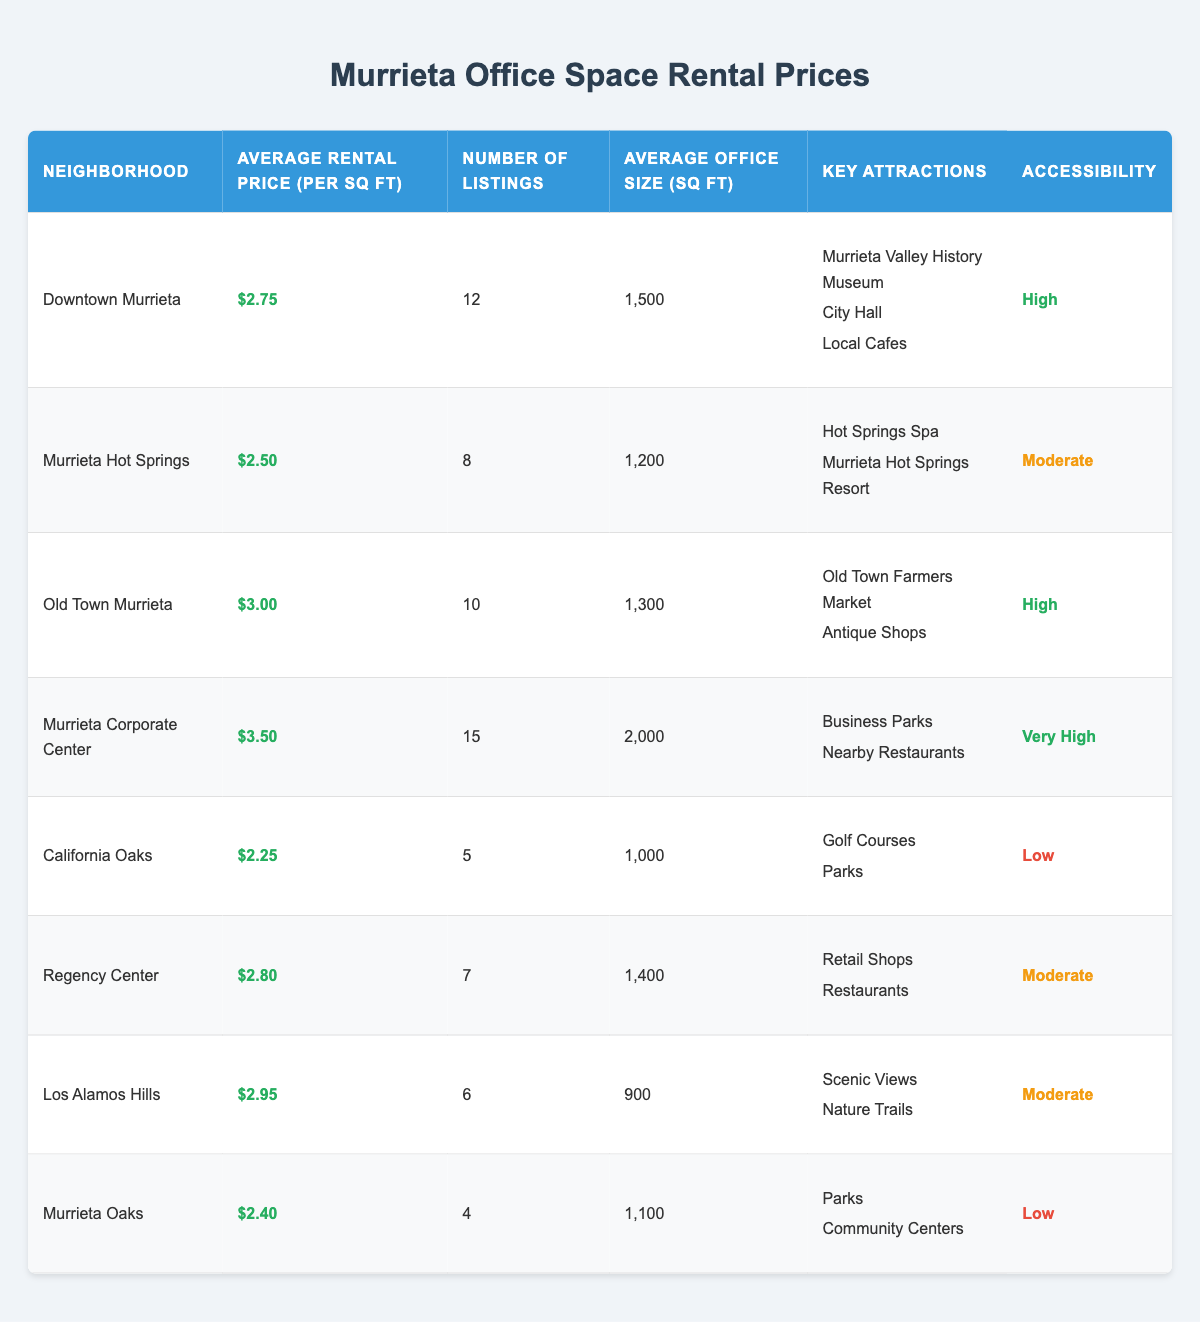What's the average rental price per square foot in Downtown Murrieta? The average rental price per square foot in Downtown Murrieta is listed in the table as $2.75.
Answer: $2.75 Which neighborhood has the highest average rental price per square foot? The neighborhood with the highest average rental price per square foot is Murrieta Corporate Center, with a price of $3.50.
Answer: Murrieta Corporate Center How many total listings are there across all neighborhoods? To find the total listings, I sum the number of listings for each neighborhood: 12 + 8 + 10 + 15 + 5 + 7 + 6 + 4 = 67.
Answer: 67 What is the average office size in square feet for Regency Center? The average office size for Regency Center is stated in the table as 1,400 square feet.
Answer: 1,400 Are there any neighborhoods with rental prices less than $2.50 per square foot? According to the table, the lowest rental price is $2.25 in California Oaks, which means there are neighborhoods with rental prices below $2.50.
Answer: Yes Which neighborhood has the lowest rental price per square foot? The neighborhood with the lowest rental price per square foot is California Oaks at $2.25.
Answer: California Oaks If you average the rental prices of California Oaks and Murrieta Hot Springs, what is the result? The rental prices are $2.25 (California Oaks) and $2.50 (Murrieta Hot Springs). The average is calculated as (2.25 + 2.50) / 2 = 2.375.
Answer: $2.375 Is the average size of office spaces larger in Downtown Murrieta or California Oaks? Downtown Murrieta has an average office size of 1,500 square feet, while California Oaks has 1,000 square feet. Therefore, Downtown Murrieta has a larger average size.
Answer: Downtown Murrieta What percentage of listings are found in the Murrieta Corporate Center? There are 15 listings in the Murrieta Corporate Center out of a total of 67 listings. The percentage is calculated as (15 / 67) * 100, which equals approximately 22.39%.
Answer: 22.39% Which neighborhood offers the most listings? The neighborhood with the most listings is Murrieta Corporate Center, which has 15 listings.
Answer: Murrieta Corporate Center How does the accessibility of Old Town Murrieta compare to California Oaks? Old Town Murrieta has an accessibility rating of High, while California Oaks has a Low rating. Therefore, Old Town Murrieta is more accessible.
Answer: Old Town Murrieta is more accessible 